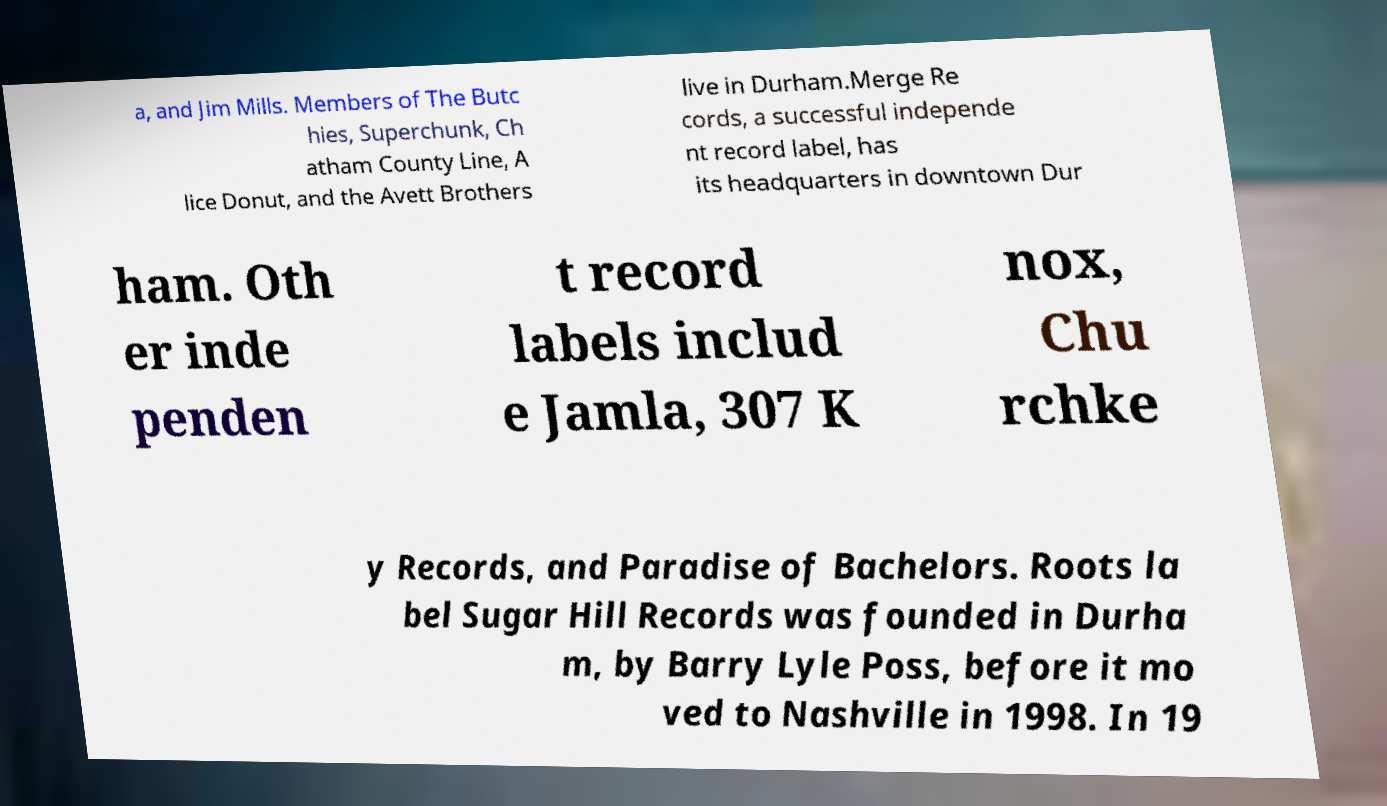I need the written content from this picture converted into text. Can you do that? a, and Jim Mills. Members of The Butc hies, Superchunk, Ch atham County Line, A lice Donut, and the Avett Brothers live in Durham.Merge Re cords, a successful independe nt record label, has its headquarters in downtown Dur ham. Oth er inde penden t record labels includ e Jamla, 307 K nox, Chu rchke y Records, and Paradise of Bachelors. Roots la bel Sugar Hill Records was founded in Durha m, by Barry Lyle Poss, before it mo ved to Nashville in 1998. In 19 